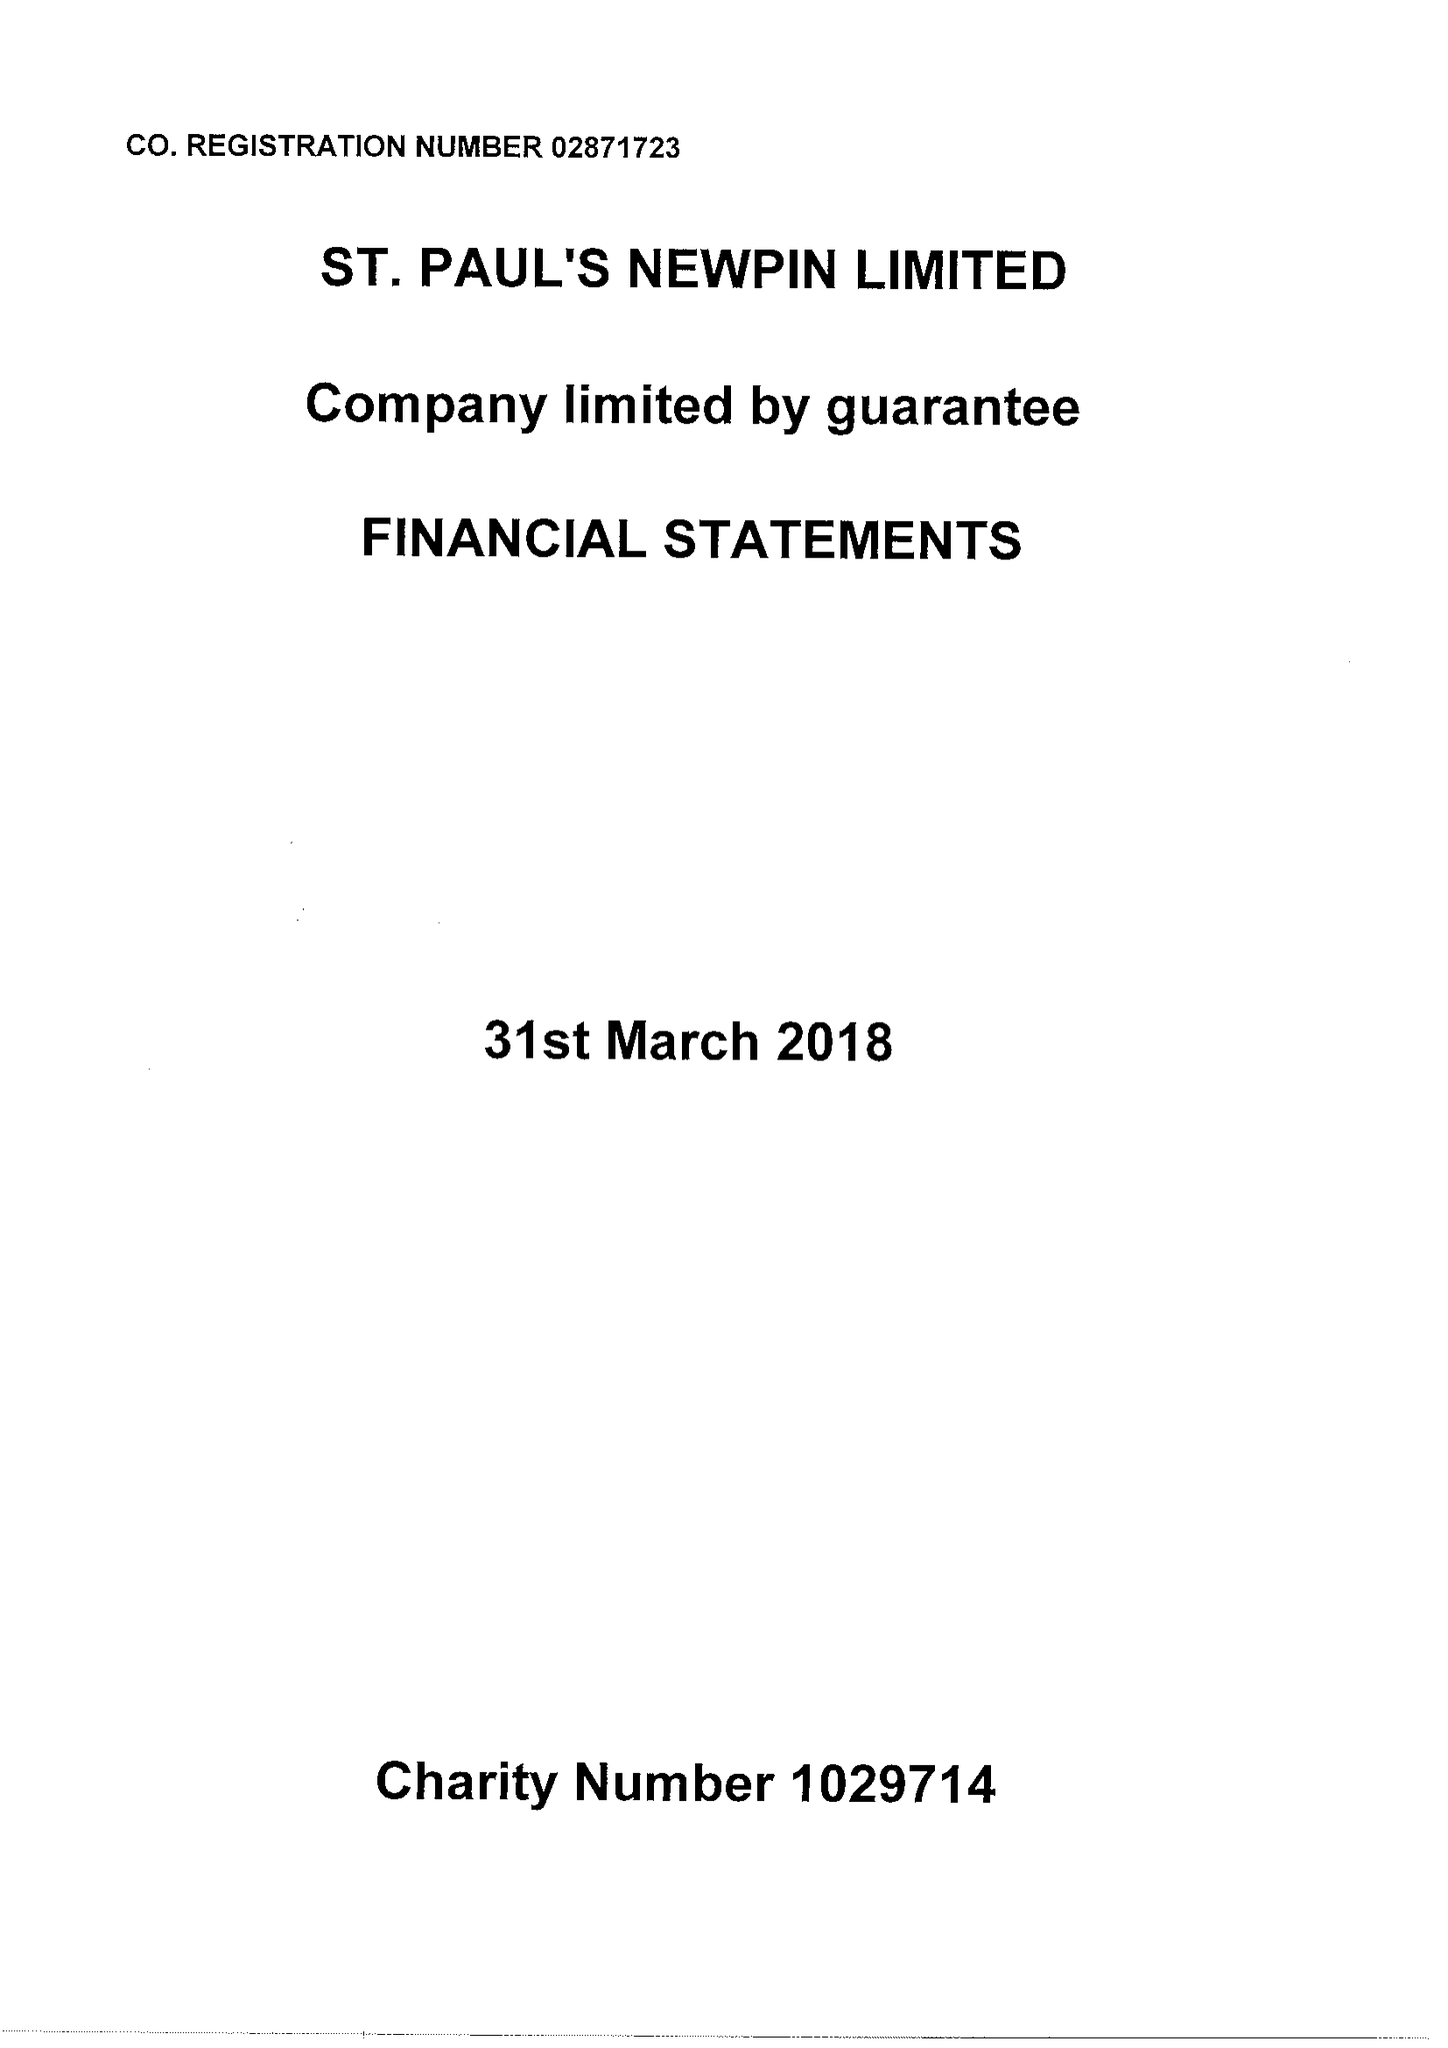What is the value for the report_date?
Answer the question using a single word or phrase. 2018-03-31 